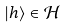<formula> <loc_0><loc_0><loc_500><loc_500>| h \rangle \in { \mathcal { H } }</formula> 